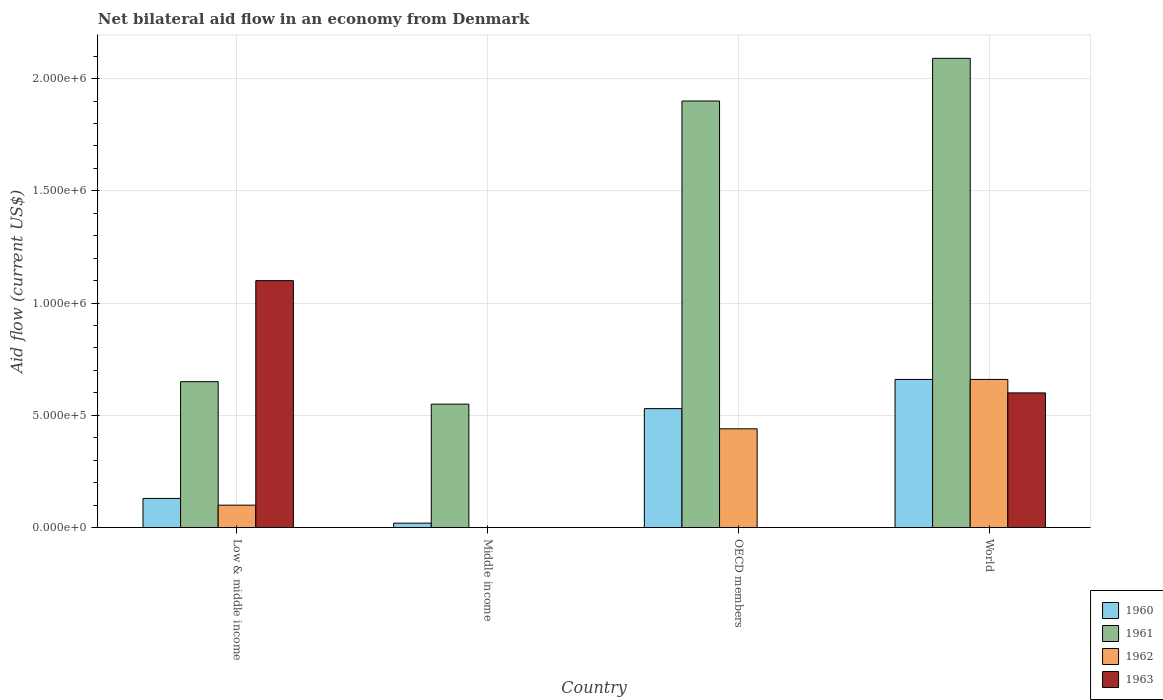How many groups of bars are there?
Your answer should be very brief. 4. Are the number of bars per tick equal to the number of legend labels?
Your answer should be compact. No. Are the number of bars on each tick of the X-axis equal?
Your answer should be compact. No. How many bars are there on the 4th tick from the left?
Provide a short and direct response. 4. What is the label of the 3rd group of bars from the left?
Ensure brevity in your answer.  OECD members. Across all countries, what is the maximum net bilateral aid flow in 1963?
Your response must be concise. 1.10e+06. Across all countries, what is the minimum net bilateral aid flow in 1963?
Offer a terse response. 0. What is the total net bilateral aid flow in 1961 in the graph?
Keep it short and to the point. 5.19e+06. What is the difference between the net bilateral aid flow in 1961 in Low & middle income and that in Middle income?
Provide a short and direct response. 1.00e+05. What is the difference between the net bilateral aid flow in 1961 in World and the net bilateral aid flow in 1962 in Low & middle income?
Offer a very short reply. 1.99e+06. What is the difference between the net bilateral aid flow of/in 1962 and net bilateral aid flow of/in 1961 in World?
Your response must be concise. -1.43e+06. In how many countries, is the net bilateral aid flow in 1960 greater than 1200000 US$?
Make the answer very short. 0. What is the ratio of the net bilateral aid flow in 1960 in Low & middle income to that in Middle income?
Provide a short and direct response. 6.5. What is the difference between the highest and the lowest net bilateral aid flow in 1961?
Provide a succinct answer. 1.54e+06. In how many countries, is the net bilateral aid flow in 1963 greater than the average net bilateral aid flow in 1963 taken over all countries?
Offer a terse response. 2. Is the sum of the net bilateral aid flow in 1960 in OECD members and World greater than the maximum net bilateral aid flow in 1963 across all countries?
Offer a very short reply. Yes. Is it the case that in every country, the sum of the net bilateral aid flow in 1963 and net bilateral aid flow in 1962 is greater than the sum of net bilateral aid flow in 1961 and net bilateral aid flow in 1960?
Your answer should be very brief. No. Are all the bars in the graph horizontal?
Offer a terse response. No. What is the difference between two consecutive major ticks on the Y-axis?
Your response must be concise. 5.00e+05. Are the values on the major ticks of Y-axis written in scientific E-notation?
Provide a succinct answer. Yes. Does the graph contain any zero values?
Your answer should be compact. Yes. Does the graph contain grids?
Make the answer very short. Yes. How are the legend labels stacked?
Your answer should be very brief. Vertical. What is the title of the graph?
Your answer should be very brief. Net bilateral aid flow in an economy from Denmark. Does "1960" appear as one of the legend labels in the graph?
Make the answer very short. Yes. What is the label or title of the X-axis?
Your answer should be very brief. Country. What is the Aid flow (current US$) in 1961 in Low & middle income?
Offer a very short reply. 6.50e+05. What is the Aid flow (current US$) in 1962 in Low & middle income?
Your answer should be very brief. 1.00e+05. What is the Aid flow (current US$) of 1963 in Low & middle income?
Offer a very short reply. 1.10e+06. What is the Aid flow (current US$) of 1960 in Middle income?
Keep it short and to the point. 2.00e+04. What is the Aid flow (current US$) in 1961 in Middle income?
Ensure brevity in your answer.  5.50e+05. What is the Aid flow (current US$) of 1962 in Middle income?
Offer a very short reply. 0. What is the Aid flow (current US$) of 1963 in Middle income?
Keep it short and to the point. 0. What is the Aid flow (current US$) of 1960 in OECD members?
Your answer should be compact. 5.30e+05. What is the Aid flow (current US$) of 1961 in OECD members?
Provide a short and direct response. 1.90e+06. What is the Aid flow (current US$) of 1962 in OECD members?
Offer a very short reply. 4.40e+05. What is the Aid flow (current US$) of 1960 in World?
Your answer should be very brief. 6.60e+05. What is the Aid flow (current US$) of 1961 in World?
Give a very brief answer. 2.09e+06. What is the Aid flow (current US$) in 1962 in World?
Offer a very short reply. 6.60e+05. What is the Aid flow (current US$) of 1963 in World?
Provide a succinct answer. 6.00e+05. Across all countries, what is the maximum Aid flow (current US$) in 1961?
Make the answer very short. 2.09e+06. Across all countries, what is the maximum Aid flow (current US$) of 1963?
Give a very brief answer. 1.10e+06. Across all countries, what is the minimum Aid flow (current US$) of 1960?
Make the answer very short. 2.00e+04. Across all countries, what is the minimum Aid flow (current US$) of 1962?
Your answer should be very brief. 0. What is the total Aid flow (current US$) in 1960 in the graph?
Offer a very short reply. 1.34e+06. What is the total Aid flow (current US$) in 1961 in the graph?
Make the answer very short. 5.19e+06. What is the total Aid flow (current US$) of 1962 in the graph?
Provide a short and direct response. 1.20e+06. What is the total Aid flow (current US$) of 1963 in the graph?
Give a very brief answer. 1.70e+06. What is the difference between the Aid flow (current US$) in 1960 in Low & middle income and that in Middle income?
Provide a succinct answer. 1.10e+05. What is the difference between the Aid flow (current US$) of 1961 in Low & middle income and that in Middle income?
Your answer should be compact. 1.00e+05. What is the difference between the Aid flow (current US$) of 1960 in Low & middle income and that in OECD members?
Your answer should be compact. -4.00e+05. What is the difference between the Aid flow (current US$) in 1961 in Low & middle income and that in OECD members?
Make the answer very short. -1.25e+06. What is the difference between the Aid flow (current US$) of 1960 in Low & middle income and that in World?
Offer a very short reply. -5.30e+05. What is the difference between the Aid flow (current US$) of 1961 in Low & middle income and that in World?
Provide a succinct answer. -1.44e+06. What is the difference between the Aid flow (current US$) in 1962 in Low & middle income and that in World?
Offer a terse response. -5.60e+05. What is the difference between the Aid flow (current US$) in 1960 in Middle income and that in OECD members?
Keep it short and to the point. -5.10e+05. What is the difference between the Aid flow (current US$) of 1961 in Middle income and that in OECD members?
Offer a very short reply. -1.35e+06. What is the difference between the Aid flow (current US$) of 1960 in Middle income and that in World?
Your response must be concise. -6.40e+05. What is the difference between the Aid flow (current US$) in 1961 in Middle income and that in World?
Offer a terse response. -1.54e+06. What is the difference between the Aid flow (current US$) in 1960 in Low & middle income and the Aid flow (current US$) in 1961 in Middle income?
Offer a terse response. -4.20e+05. What is the difference between the Aid flow (current US$) in 1960 in Low & middle income and the Aid flow (current US$) in 1961 in OECD members?
Offer a very short reply. -1.77e+06. What is the difference between the Aid flow (current US$) of 1960 in Low & middle income and the Aid flow (current US$) of 1962 in OECD members?
Keep it short and to the point. -3.10e+05. What is the difference between the Aid flow (current US$) in 1961 in Low & middle income and the Aid flow (current US$) in 1962 in OECD members?
Your response must be concise. 2.10e+05. What is the difference between the Aid flow (current US$) of 1960 in Low & middle income and the Aid flow (current US$) of 1961 in World?
Ensure brevity in your answer.  -1.96e+06. What is the difference between the Aid flow (current US$) of 1960 in Low & middle income and the Aid flow (current US$) of 1962 in World?
Provide a succinct answer. -5.30e+05. What is the difference between the Aid flow (current US$) in 1960 in Low & middle income and the Aid flow (current US$) in 1963 in World?
Give a very brief answer. -4.70e+05. What is the difference between the Aid flow (current US$) of 1962 in Low & middle income and the Aid flow (current US$) of 1963 in World?
Your response must be concise. -5.00e+05. What is the difference between the Aid flow (current US$) in 1960 in Middle income and the Aid flow (current US$) in 1961 in OECD members?
Keep it short and to the point. -1.88e+06. What is the difference between the Aid flow (current US$) of 1960 in Middle income and the Aid flow (current US$) of 1962 in OECD members?
Offer a very short reply. -4.20e+05. What is the difference between the Aid flow (current US$) in 1960 in Middle income and the Aid flow (current US$) in 1961 in World?
Your answer should be very brief. -2.07e+06. What is the difference between the Aid flow (current US$) in 1960 in Middle income and the Aid flow (current US$) in 1962 in World?
Your response must be concise. -6.40e+05. What is the difference between the Aid flow (current US$) of 1960 in Middle income and the Aid flow (current US$) of 1963 in World?
Offer a terse response. -5.80e+05. What is the difference between the Aid flow (current US$) in 1961 in Middle income and the Aid flow (current US$) in 1962 in World?
Make the answer very short. -1.10e+05. What is the difference between the Aid flow (current US$) of 1961 in Middle income and the Aid flow (current US$) of 1963 in World?
Provide a short and direct response. -5.00e+04. What is the difference between the Aid flow (current US$) of 1960 in OECD members and the Aid flow (current US$) of 1961 in World?
Provide a short and direct response. -1.56e+06. What is the difference between the Aid flow (current US$) in 1960 in OECD members and the Aid flow (current US$) in 1962 in World?
Offer a very short reply. -1.30e+05. What is the difference between the Aid flow (current US$) in 1961 in OECD members and the Aid flow (current US$) in 1962 in World?
Ensure brevity in your answer.  1.24e+06. What is the difference between the Aid flow (current US$) in 1961 in OECD members and the Aid flow (current US$) in 1963 in World?
Keep it short and to the point. 1.30e+06. What is the difference between the Aid flow (current US$) in 1962 in OECD members and the Aid flow (current US$) in 1963 in World?
Your answer should be compact. -1.60e+05. What is the average Aid flow (current US$) in 1960 per country?
Provide a short and direct response. 3.35e+05. What is the average Aid flow (current US$) of 1961 per country?
Offer a terse response. 1.30e+06. What is the average Aid flow (current US$) of 1962 per country?
Your answer should be compact. 3.00e+05. What is the average Aid flow (current US$) of 1963 per country?
Offer a terse response. 4.25e+05. What is the difference between the Aid flow (current US$) in 1960 and Aid flow (current US$) in 1961 in Low & middle income?
Your answer should be very brief. -5.20e+05. What is the difference between the Aid flow (current US$) of 1960 and Aid flow (current US$) of 1962 in Low & middle income?
Offer a terse response. 3.00e+04. What is the difference between the Aid flow (current US$) in 1960 and Aid flow (current US$) in 1963 in Low & middle income?
Your response must be concise. -9.70e+05. What is the difference between the Aid flow (current US$) of 1961 and Aid flow (current US$) of 1963 in Low & middle income?
Give a very brief answer. -4.50e+05. What is the difference between the Aid flow (current US$) of 1960 and Aid flow (current US$) of 1961 in Middle income?
Provide a succinct answer. -5.30e+05. What is the difference between the Aid flow (current US$) in 1960 and Aid flow (current US$) in 1961 in OECD members?
Offer a very short reply. -1.37e+06. What is the difference between the Aid flow (current US$) in 1961 and Aid flow (current US$) in 1962 in OECD members?
Ensure brevity in your answer.  1.46e+06. What is the difference between the Aid flow (current US$) in 1960 and Aid flow (current US$) in 1961 in World?
Your answer should be very brief. -1.43e+06. What is the difference between the Aid flow (current US$) of 1960 and Aid flow (current US$) of 1963 in World?
Your answer should be very brief. 6.00e+04. What is the difference between the Aid flow (current US$) of 1961 and Aid flow (current US$) of 1962 in World?
Provide a short and direct response. 1.43e+06. What is the difference between the Aid flow (current US$) of 1961 and Aid flow (current US$) of 1963 in World?
Ensure brevity in your answer.  1.49e+06. What is the ratio of the Aid flow (current US$) of 1961 in Low & middle income to that in Middle income?
Keep it short and to the point. 1.18. What is the ratio of the Aid flow (current US$) in 1960 in Low & middle income to that in OECD members?
Make the answer very short. 0.25. What is the ratio of the Aid flow (current US$) in 1961 in Low & middle income to that in OECD members?
Ensure brevity in your answer.  0.34. What is the ratio of the Aid flow (current US$) of 1962 in Low & middle income to that in OECD members?
Your response must be concise. 0.23. What is the ratio of the Aid flow (current US$) in 1960 in Low & middle income to that in World?
Make the answer very short. 0.2. What is the ratio of the Aid flow (current US$) in 1961 in Low & middle income to that in World?
Your answer should be very brief. 0.31. What is the ratio of the Aid flow (current US$) in 1962 in Low & middle income to that in World?
Offer a very short reply. 0.15. What is the ratio of the Aid flow (current US$) of 1963 in Low & middle income to that in World?
Ensure brevity in your answer.  1.83. What is the ratio of the Aid flow (current US$) in 1960 in Middle income to that in OECD members?
Provide a succinct answer. 0.04. What is the ratio of the Aid flow (current US$) of 1961 in Middle income to that in OECD members?
Provide a succinct answer. 0.29. What is the ratio of the Aid flow (current US$) in 1960 in Middle income to that in World?
Offer a terse response. 0.03. What is the ratio of the Aid flow (current US$) of 1961 in Middle income to that in World?
Provide a succinct answer. 0.26. What is the ratio of the Aid flow (current US$) in 1960 in OECD members to that in World?
Your answer should be compact. 0.8. What is the ratio of the Aid flow (current US$) of 1962 in OECD members to that in World?
Your answer should be very brief. 0.67. What is the difference between the highest and the second highest Aid flow (current US$) of 1961?
Ensure brevity in your answer.  1.90e+05. What is the difference between the highest and the lowest Aid flow (current US$) in 1960?
Give a very brief answer. 6.40e+05. What is the difference between the highest and the lowest Aid flow (current US$) in 1961?
Give a very brief answer. 1.54e+06. What is the difference between the highest and the lowest Aid flow (current US$) of 1962?
Provide a succinct answer. 6.60e+05. What is the difference between the highest and the lowest Aid flow (current US$) in 1963?
Provide a short and direct response. 1.10e+06. 